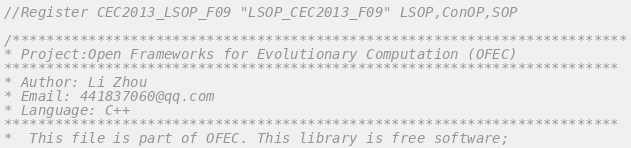<code> <loc_0><loc_0><loc_500><loc_500><_C_>//Register CEC2013_LSOP_F09 "LSOP_CEC2013_F09" LSOP,ConOP,SOP

/*************************************************************************
* Project:Open Frameworks for Evolutionary Computation (OFEC)
*************************************************************************
* Author: Li Zhou
* Email: 441837060@qq.com
* Language: C++
*************************************************************************
*  This file is part of OFEC. This library is free software;</code> 